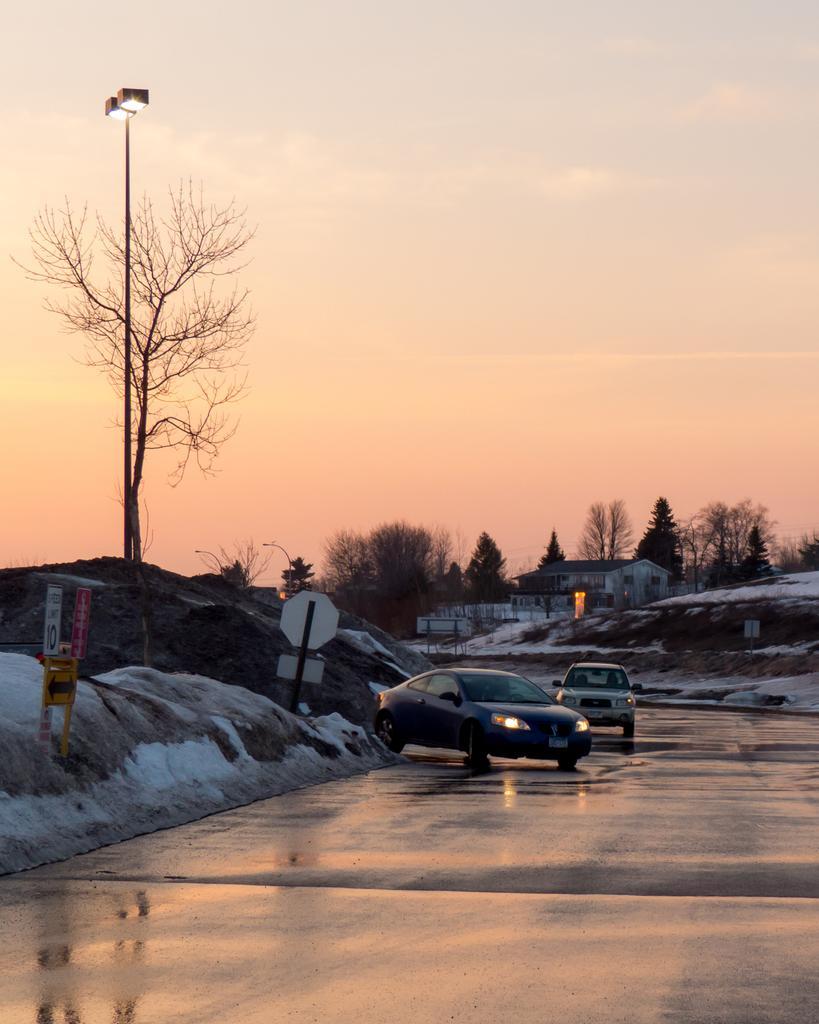Can you describe this image briefly? Here I can see two cars on the road. On both sides of the road I can see the snow and poles. In the background there are some trees and a building. On the top of the image I can see the sky. 